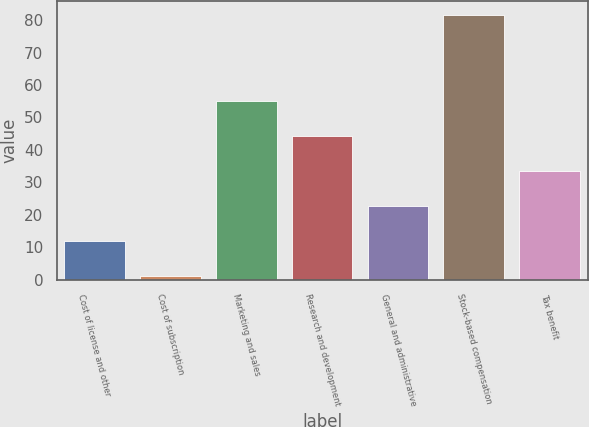<chart> <loc_0><loc_0><loc_500><loc_500><bar_chart><fcel>Cost of license and other<fcel>Cost of subscription<fcel>Marketing and sales<fcel>Research and development<fcel>General and administrative<fcel>Stock-based compensation<fcel>Tax benefit<nl><fcel>11.96<fcel>1.2<fcel>55<fcel>44.24<fcel>22.72<fcel>81.7<fcel>33.48<nl></chart> 